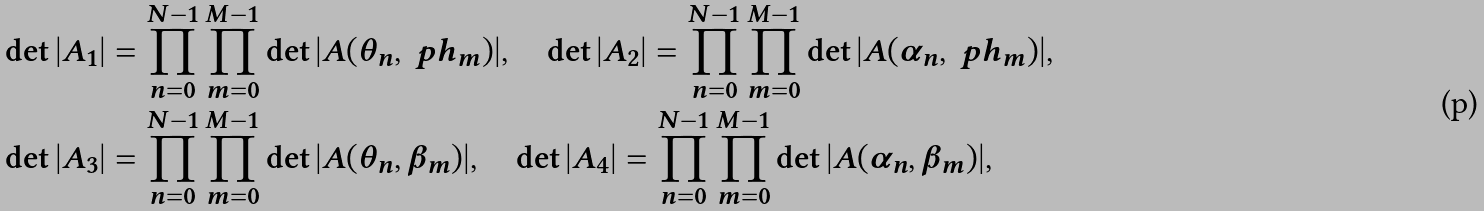Convert formula to latex. <formula><loc_0><loc_0><loc_500><loc_500>& \det | A _ { 1 } | = \prod _ { n = 0 } ^ { N - 1 } \prod _ { m = 0 } ^ { M - 1 } \det | A ( \theta _ { n } , \ p h _ { m } ) | , \quad \det | A _ { 2 } | = \prod _ { n = 0 } ^ { N - 1 } \prod _ { m = 0 } ^ { M - 1 } \det | A ( \alpha _ { n } , \ p h _ { m } ) | , \\ & \det | A _ { 3 } | = \prod _ { n = 0 } ^ { N - 1 } \prod _ { m = 0 } ^ { M - 1 } \det | A ( \theta _ { n } , \beta _ { m } ) | , \quad \det | A _ { 4 } | = \prod _ { n = 0 } ^ { N - 1 } \prod _ { m = 0 } ^ { M - 1 } \det | A ( \alpha _ { n } , \beta _ { m } ) | ,</formula> 